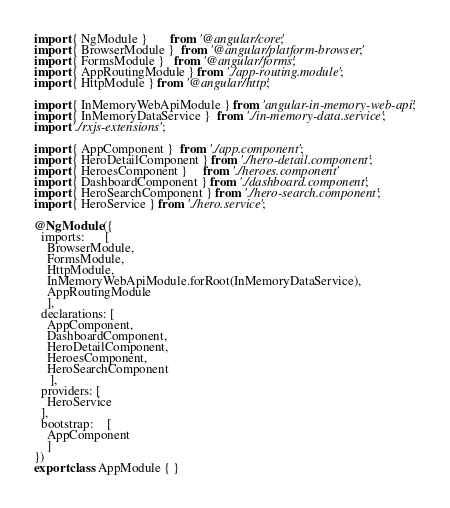<code> <loc_0><loc_0><loc_500><loc_500><_TypeScript_>import { NgModule }       from '@angular/core';
import { BrowserModule }  from '@angular/platform-browser';
import { FormsModule }   from '@angular/forms';
import { AppRoutingModule } from './app-routing.module';
import { HttpModule } from '@angular/http';

import { InMemoryWebApiModule } from 'angular-in-memory-web-api';
import { InMemoryDataService }  from './in-memory-data.service';
import './rxjs-extensions';

import { AppComponent }  from './app.component';
import { HeroDetailComponent } from './hero-detail.component';
import { HeroesComponent }     from './heroes.component'
import { DashboardComponent } from './dashboard.component';
import { HeroSearchComponent } from './hero-search.component';
import { HeroService } from './hero.service';

@NgModule({
  imports:      [ 
    BrowserModule,
    FormsModule,
    HttpModule,
    InMemoryWebApiModule.forRoot(InMemoryDataService),
    AppRoutingModule
    ],
  declarations: [ 
    AppComponent,
    DashboardComponent,
    HeroDetailComponent,
    HeroesComponent,
    HeroSearchComponent
     ],
  providers: [
    HeroService
  ],
  bootstrap:    [ 
    AppComponent 
    ]
})
export class AppModule { }
</code> 